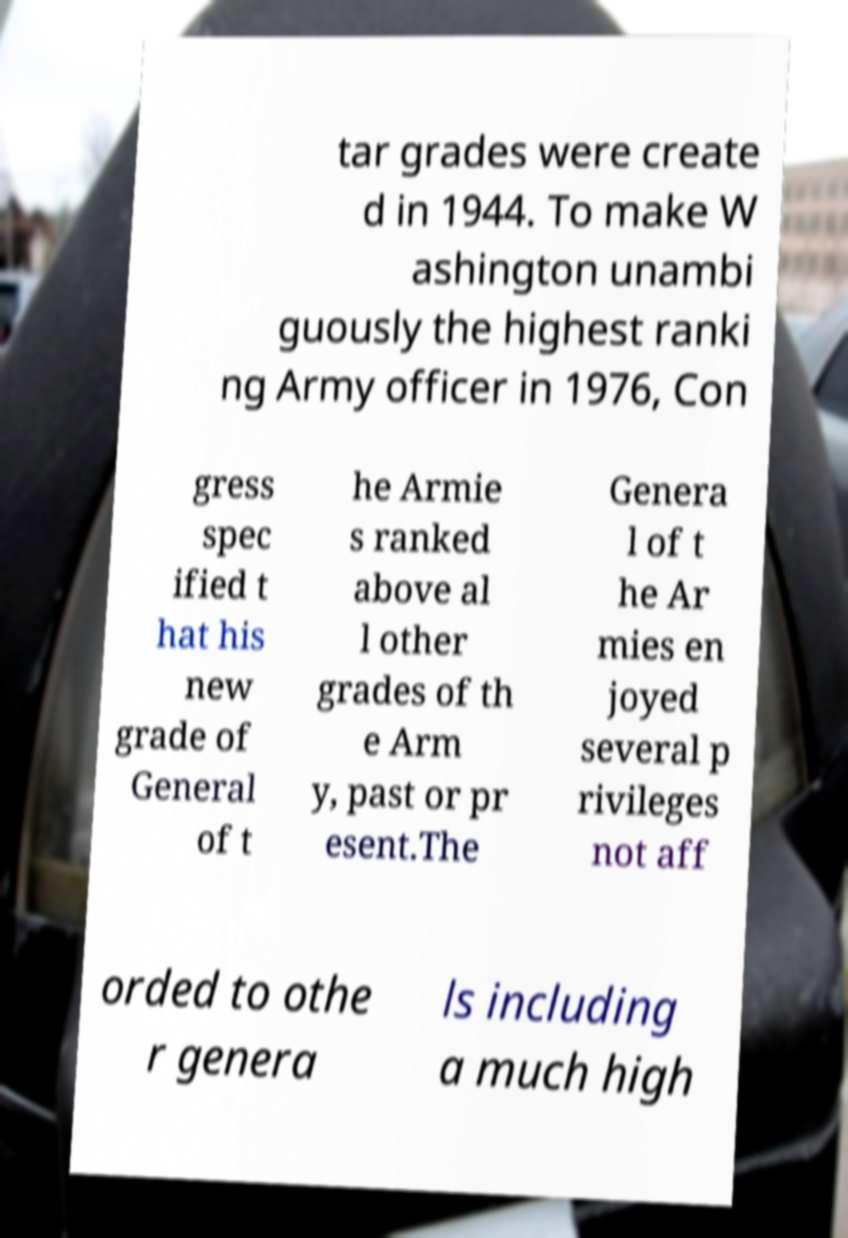What messages or text are displayed in this image? I need them in a readable, typed format. tar grades were create d in 1944. To make W ashington unambi guously the highest ranki ng Army officer in 1976, Con gress spec ified t hat his new grade of General of t he Armie s ranked above al l other grades of th e Arm y, past or pr esent.The Genera l of t he Ar mies en joyed several p rivileges not aff orded to othe r genera ls including a much high 